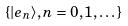Convert formula to latex. <formula><loc_0><loc_0><loc_500><loc_500>\{ | e _ { n } \rangle , n = 0 , 1 , \dots \}</formula> 